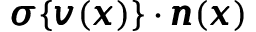<formula> <loc_0><loc_0><loc_500><loc_500>{ \pm b \sigma } \{ { \pm b v } ( { \pm b x } ) \} \cdot { \pm b n } ( { \pm b x } )</formula> 